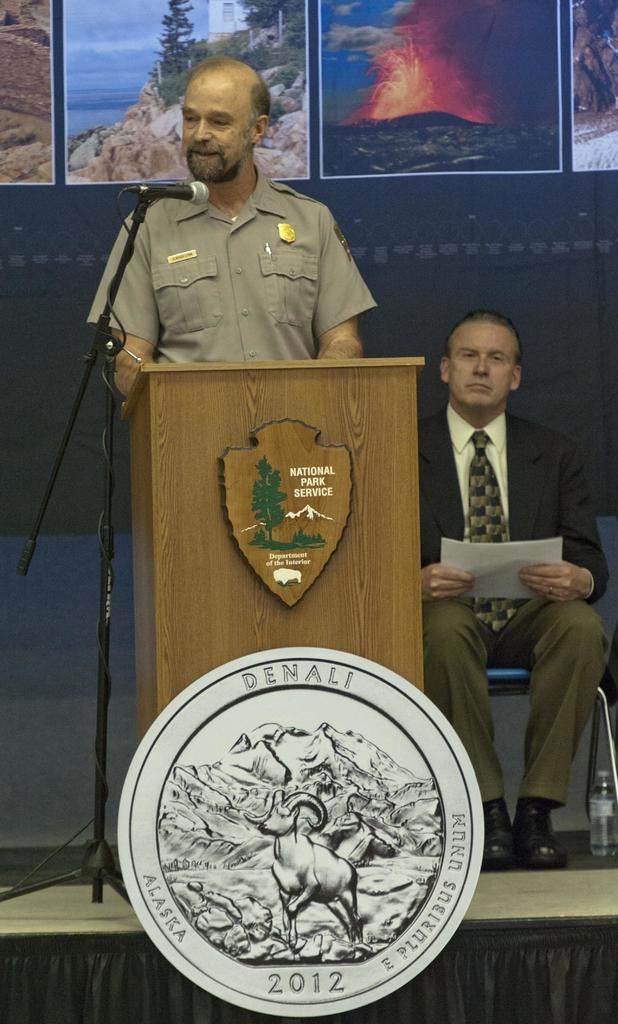<image>
Render a clear and concise summary of the photo. The man giving the talk is from the national park service. 